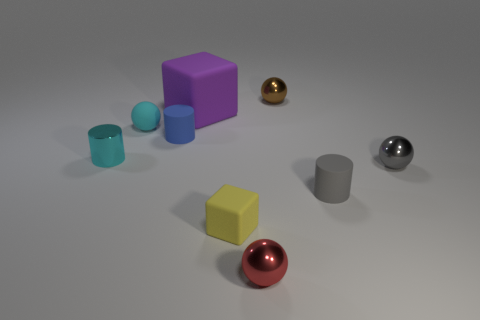Is there anything else that has the same size as the purple rubber cube?
Ensure brevity in your answer.  No. How many other objects are the same material as the small gray sphere?
Give a very brief answer. 3. Are there more rubber cylinders that are behind the small gray sphere than brown balls left of the small cyan metallic cylinder?
Your answer should be very brief. Yes. How many tiny yellow matte cubes are to the right of the tiny gray rubber thing?
Offer a terse response. 0. Do the tiny blue thing and the cylinder that is in front of the metal cylinder have the same material?
Ensure brevity in your answer.  Yes. Do the brown sphere and the large object have the same material?
Make the answer very short. No. Is there a thing on the right side of the small rubber thing that is in front of the gray matte object?
Your answer should be very brief. Yes. How many tiny objects are left of the small red object and behind the small cyan sphere?
Make the answer very short. 0. What is the shape of the cyan object that is on the left side of the cyan sphere?
Keep it short and to the point. Cylinder. What number of purple blocks have the same size as the brown shiny object?
Provide a succinct answer. 0. 